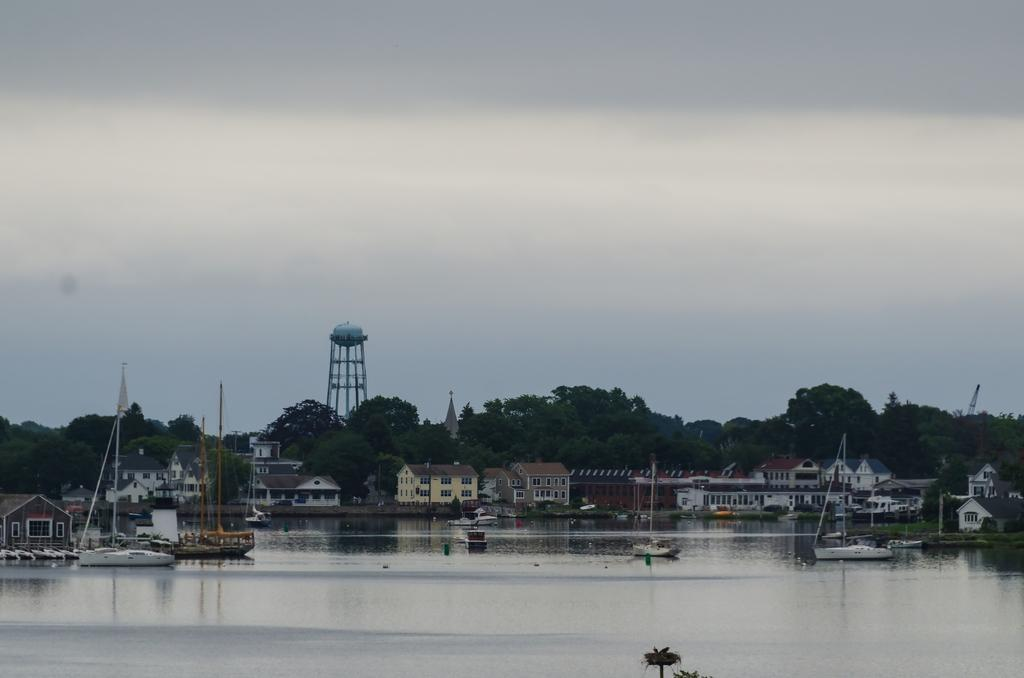What is on the water in the image? There are boats on the water in the image. What can be seen in the background of the image? There are buildings and trees in the background of the image. What colors are the buildings in the image? The buildings are in white, cream, and brown colors. What color are the trees in the image? The trees are green. What is the color of the sky in the image? The sky is white in the image. Where is the badge located in the image? There is no badge present in the image. How long does it take for the boats to travel a minute in the image? The image is a still photograph and does not show the boats moving, so it is not possible to determine how long it would take for them to travel a minute. 